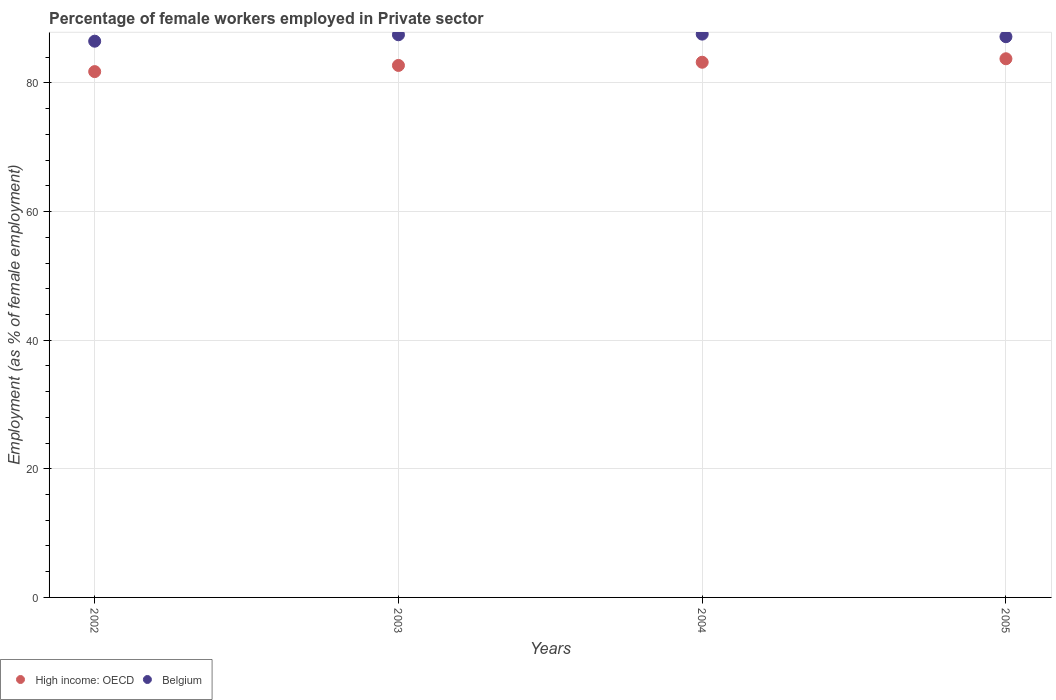Is the number of dotlines equal to the number of legend labels?
Offer a terse response. Yes. What is the percentage of females employed in Private sector in Belgium in 2003?
Ensure brevity in your answer.  87.5. Across all years, what is the maximum percentage of females employed in Private sector in Belgium?
Offer a terse response. 87.6. Across all years, what is the minimum percentage of females employed in Private sector in Belgium?
Provide a short and direct response. 86.5. What is the total percentage of females employed in Private sector in High income: OECD in the graph?
Give a very brief answer. 331.5. What is the difference between the percentage of females employed in Private sector in High income: OECD in 2004 and that in 2005?
Ensure brevity in your answer.  -0.54. What is the difference between the percentage of females employed in Private sector in High income: OECD in 2004 and the percentage of females employed in Private sector in Belgium in 2003?
Give a very brief answer. -4.27. What is the average percentage of females employed in Private sector in Belgium per year?
Provide a short and direct response. 87.2. In the year 2003, what is the difference between the percentage of females employed in Private sector in High income: OECD and percentage of females employed in Private sector in Belgium?
Offer a very short reply. -4.77. What is the ratio of the percentage of females employed in Private sector in High income: OECD in 2002 to that in 2004?
Provide a short and direct response. 0.98. What is the difference between the highest and the second highest percentage of females employed in Private sector in Belgium?
Provide a short and direct response. 0.1. What is the difference between the highest and the lowest percentage of females employed in Private sector in Belgium?
Provide a succinct answer. 1.1. In how many years, is the percentage of females employed in Private sector in High income: OECD greater than the average percentage of females employed in Private sector in High income: OECD taken over all years?
Offer a terse response. 2. Is the sum of the percentage of females employed in Private sector in Belgium in 2003 and 2005 greater than the maximum percentage of females employed in Private sector in High income: OECD across all years?
Give a very brief answer. Yes. Is the percentage of females employed in Private sector in High income: OECD strictly greater than the percentage of females employed in Private sector in Belgium over the years?
Provide a short and direct response. No. What is the difference between two consecutive major ticks on the Y-axis?
Your answer should be compact. 20. Does the graph contain any zero values?
Ensure brevity in your answer.  No. Does the graph contain grids?
Provide a short and direct response. Yes. What is the title of the graph?
Ensure brevity in your answer.  Percentage of female workers employed in Private sector. Does "Slovak Republic" appear as one of the legend labels in the graph?
Your answer should be compact. No. What is the label or title of the X-axis?
Offer a terse response. Years. What is the label or title of the Y-axis?
Ensure brevity in your answer.  Employment (as % of female employment). What is the Employment (as % of female employment) in High income: OECD in 2002?
Make the answer very short. 81.77. What is the Employment (as % of female employment) in Belgium in 2002?
Your response must be concise. 86.5. What is the Employment (as % of female employment) in High income: OECD in 2003?
Offer a very short reply. 82.73. What is the Employment (as % of female employment) in Belgium in 2003?
Give a very brief answer. 87.5. What is the Employment (as % of female employment) in High income: OECD in 2004?
Provide a succinct answer. 83.23. What is the Employment (as % of female employment) of Belgium in 2004?
Offer a very short reply. 87.6. What is the Employment (as % of female employment) of High income: OECD in 2005?
Your answer should be compact. 83.77. What is the Employment (as % of female employment) in Belgium in 2005?
Give a very brief answer. 87.2. Across all years, what is the maximum Employment (as % of female employment) in High income: OECD?
Provide a succinct answer. 83.77. Across all years, what is the maximum Employment (as % of female employment) in Belgium?
Keep it short and to the point. 87.6. Across all years, what is the minimum Employment (as % of female employment) of High income: OECD?
Provide a succinct answer. 81.77. Across all years, what is the minimum Employment (as % of female employment) of Belgium?
Provide a succinct answer. 86.5. What is the total Employment (as % of female employment) in High income: OECD in the graph?
Keep it short and to the point. 331.5. What is the total Employment (as % of female employment) in Belgium in the graph?
Provide a short and direct response. 348.8. What is the difference between the Employment (as % of female employment) in High income: OECD in 2002 and that in 2003?
Ensure brevity in your answer.  -0.96. What is the difference between the Employment (as % of female employment) of Belgium in 2002 and that in 2003?
Provide a succinct answer. -1. What is the difference between the Employment (as % of female employment) of High income: OECD in 2002 and that in 2004?
Provide a succinct answer. -1.46. What is the difference between the Employment (as % of female employment) in High income: OECD in 2002 and that in 2005?
Your answer should be very brief. -2. What is the difference between the Employment (as % of female employment) in Belgium in 2002 and that in 2005?
Your answer should be very brief. -0.7. What is the difference between the Employment (as % of female employment) of High income: OECD in 2003 and that in 2004?
Keep it short and to the point. -0.5. What is the difference between the Employment (as % of female employment) in High income: OECD in 2003 and that in 2005?
Give a very brief answer. -1.04. What is the difference between the Employment (as % of female employment) of High income: OECD in 2004 and that in 2005?
Ensure brevity in your answer.  -0.54. What is the difference between the Employment (as % of female employment) of Belgium in 2004 and that in 2005?
Your response must be concise. 0.4. What is the difference between the Employment (as % of female employment) of High income: OECD in 2002 and the Employment (as % of female employment) of Belgium in 2003?
Provide a short and direct response. -5.73. What is the difference between the Employment (as % of female employment) in High income: OECD in 2002 and the Employment (as % of female employment) in Belgium in 2004?
Offer a terse response. -5.83. What is the difference between the Employment (as % of female employment) of High income: OECD in 2002 and the Employment (as % of female employment) of Belgium in 2005?
Offer a terse response. -5.43. What is the difference between the Employment (as % of female employment) in High income: OECD in 2003 and the Employment (as % of female employment) in Belgium in 2004?
Keep it short and to the point. -4.87. What is the difference between the Employment (as % of female employment) of High income: OECD in 2003 and the Employment (as % of female employment) of Belgium in 2005?
Keep it short and to the point. -4.47. What is the difference between the Employment (as % of female employment) in High income: OECD in 2004 and the Employment (as % of female employment) in Belgium in 2005?
Offer a very short reply. -3.97. What is the average Employment (as % of female employment) in High income: OECD per year?
Keep it short and to the point. 82.87. What is the average Employment (as % of female employment) in Belgium per year?
Offer a very short reply. 87.2. In the year 2002, what is the difference between the Employment (as % of female employment) of High income: OECD and Employment (as % of female employment) of Belgium?
Give a very brief answer. -4.73. In the year 2003, what is the difference between the Employment (as % of female employment) in High income: OECD and Employment (as % of female employment) in Belgium?
Ensure brevity in your answer.  -4.77. In the year 2004, what is the difference between the Employment (as % of female employment) of High income: OECD and Employment (as % of female employment) of Belgium?
Offer a terse response. -4.37. In the year 2005, what is the difference between the Employment (as % of female employment) in High income: OECD and Employment (as % of female employment) in Belgium?
Your answer should be compact. -3.43. What is the ratio of the Employment (as % of female employment) of High income: OECD in 2002 to that in 2003?
Keep it short and to the point. 0.99. What is the ratio of the Employment (as % of female employment) in High income: OECD in 2002 to that in 2004?
Offer a terse response. 0.98. What is the ratio of the Employment (as % of female employment) in Belgium in 2002 to that in 2004?
Offer a very short reply. 0.99. What is the ratio of the Employment (as % of female employment) in High income: OECD in 2002 to that in 2005?
Offer a very short reply. 0.98. What is the ratio of the Employment (as % of female employment) of High income: OECD in 2003 to that in 2005?
Ensure brevity in your answer.  0.99. What is the ratio of the Employment (as % of female employment) in Belgium in 2003 to that in 2005?
Your answer should be very brief. 1. What is the ratio of the Employment (as % of female employment) of High income: OECD in 2004 to that in 2005?
Provide a succinct answer. 0.99. What is the ratio of the Employment (as % of female employment) in Belgium in 2004 to that in 2005?
Make the answer very short. 1. What is the difference between the highest and the second highest Employment (as % of female employment) in High income: OECD?
Your response must be concise. 0.54. What is the difference between the highest and the second highest Employment (as % of female employment) of Belgium?
Offer a terse response. 0.1. What is the difference between the highest and the lowest Employment (as % of female employment) of High income: OECD?
Offer a terse response. 2. 